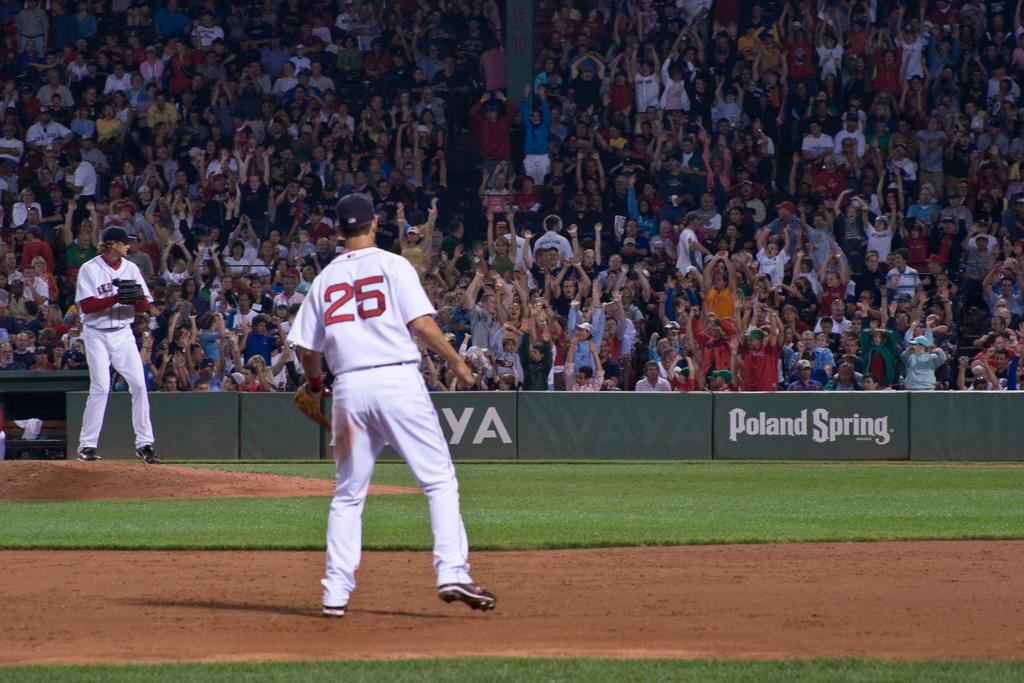What city is the banner?
Ensure brevity in your answer.  Poland spring. 